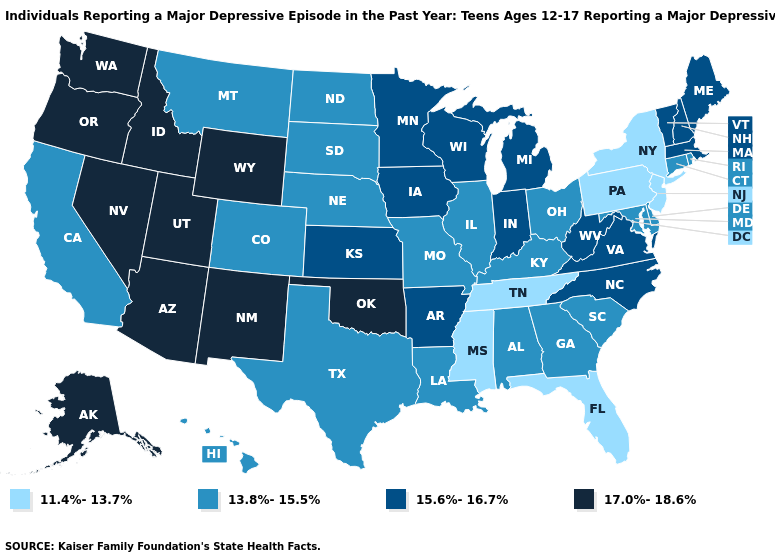Name the states that have a value in the range 13.8%-15.5%?
Quick response, please. Alabama, California, Colorado, Connecticut, Delaware, Georgia, Hawaii, Illinois, Kentucky, Louisiana, Maryland, Missouri, Montana, Nebraska, North Dakota, Ohio, Rhode Island, South Carolina, South Dakota, Texas. Does Nebraska have the highest value in the MidWest?
Be succinct. No. What is the lowest value in the MidWest?
Concise answer only. 13.8%-15.5%. Does Colorado have the same value as Delaware?
Concise answer only. Yes. Which states hav the highest value in the South?
Keep it brief. Oklahoma. Name the states that have a value in the range 13.8%-15.5%?
Be succinct. Alabama, California, Colorado, Connecticut, Delaware, Georgia, Hawaii, Illinois, Kentucky, Louisiana, Maryland, Missouri, Montana, Nebraska, North Dakota, Ohio, Rhode Island, South Carolina, South Dakota, Texas. Does Oklahoma have a lower value than Minnesota?
Quick response, please. No. What is the value of Louisiana?
Give a very brief answer. 13.8%-15.5%. Among the states that border Arkansas , which have the highest value?
Concise answer only. Oklahoma. What is the lowest value in the MidWest?
Concise answer only. 13.8%-15.5%. Does Washington have the highest value in the West?
Concise answer only. Yes. What is the value of Wisconsin?
Keep it brief. 15.6%-16.7%. Does the first symbol in the legend represent the smallest category?
Short answer required. Yes. Does Texas have the same value as Wyoming?
Give a very brief answer. No. Does Louisiana have a lower value than Virginia?
Write a very short answer. Yes. 